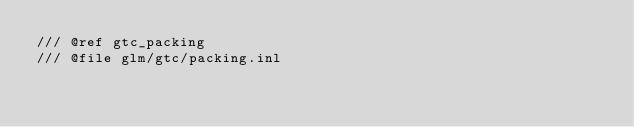Convert code to text. <code><loc_0><loc_0><loc_500><loc_500><_C++_>/// @ref gtc_packing
/// @file glm/gtc/packing.inl
</code> 